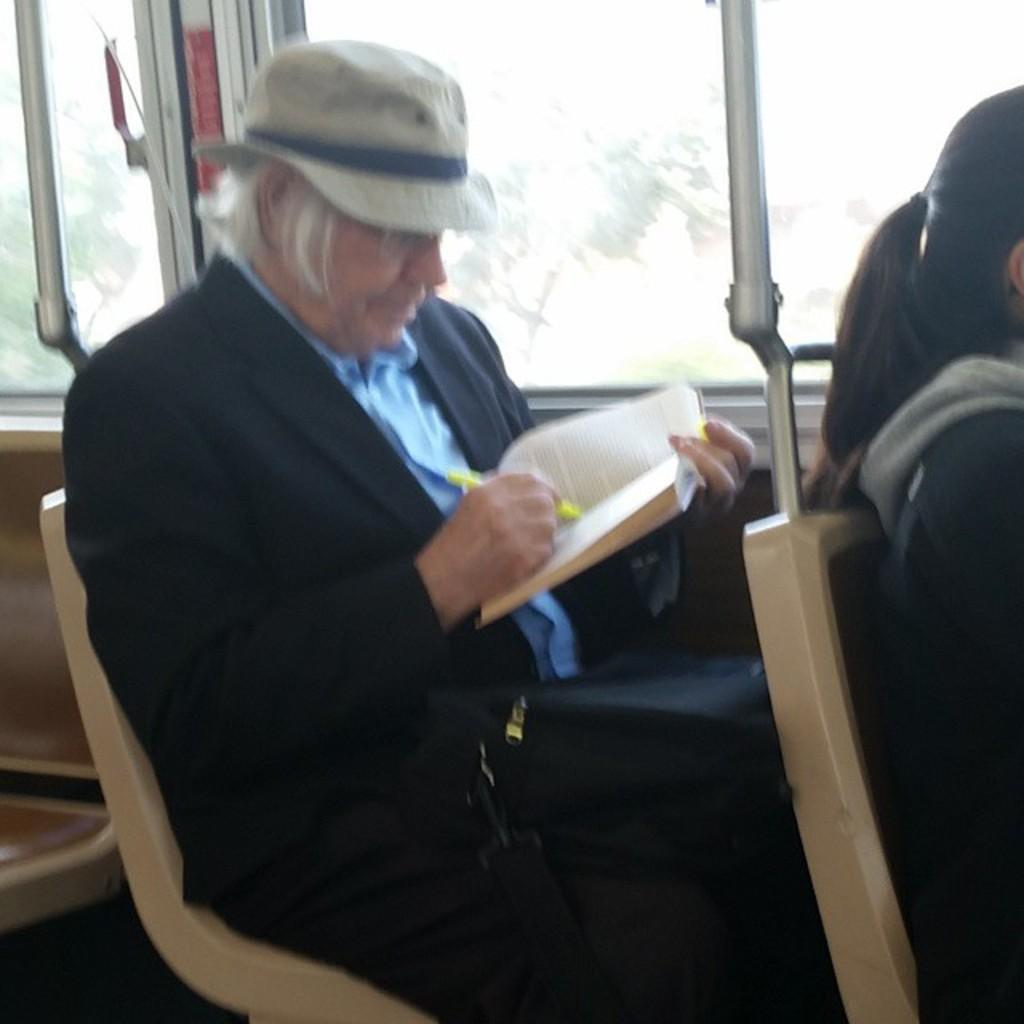What are the persons in the image doing? The persons in the image are sitting on chairs and holding books. What else are the persons holding in the image? The persons are also holding pens. What can be seen through the windows in the image? The windows in the image allow us to see the outside environment. What type of gold jewelry is the person wearing in the image? There is no gold jewelry visible in the image; the persons are holding books and pens. How much sand can be seen on the floor in the image? There is no sand present in the image; it features persons sitting on chairs and holding books and pens. 